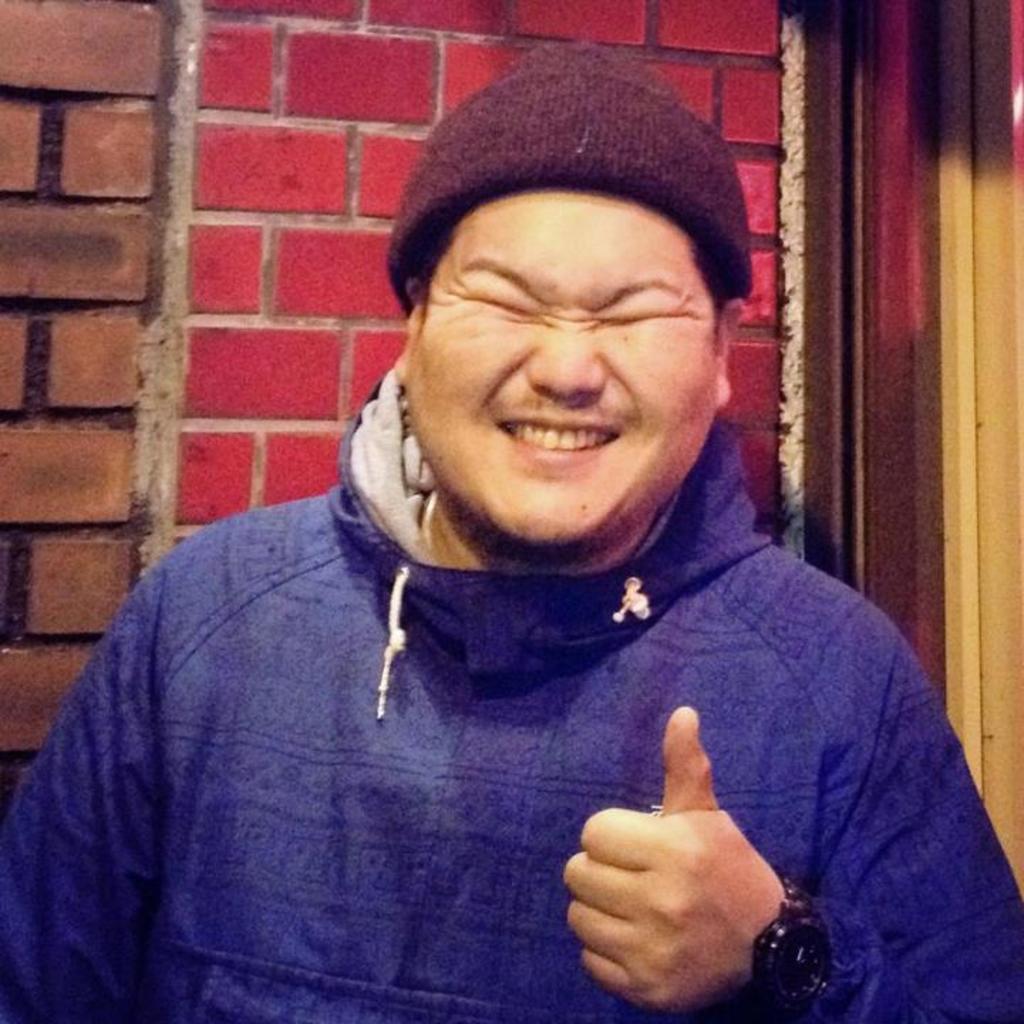In one or two sentences, can you explain what this image depicts? In this image we can see a man. He is wearing a cap and a hoodie. In the background, we can see a wall. It seems like a door on the right side of the image. 